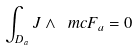Convert formula to latex. <formula><loc_0><loc_0><loc_500><loc_500>\int _ { D _ { a } } J \wedge \ m c { F } _ { a } = 0</formula> 